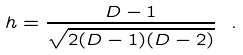<formula> <loc_0><loc_0><loc_500><loc_500>h = \frac { D - 1 } { \sqrt { 2 ( D - 1 ) ( D - 2 ) } } \ .</formula> 